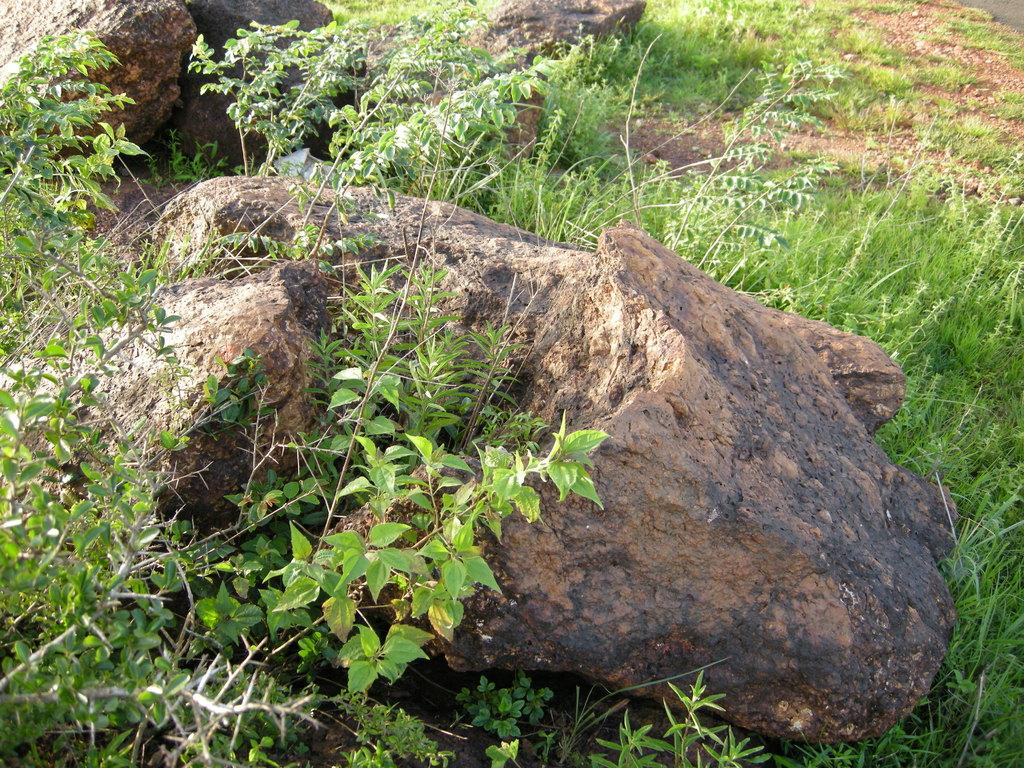What type of natural elements can be seen in the image? There are rocks, plants, and grass in the image. Can you describe the plants in the image? The image contains plants, but their specific type cannot be determined from the provided facts. What is the ground covered with in the image? The ground is covered with grass in the image. What type of paper can be seen in the image? There is no paper present in the image; it features rocks, plants, and grass. What is the aftermath of the event depicted in the image? There is no event depicted in the image, as it features rocks, plants, and grass in a natural setting. 